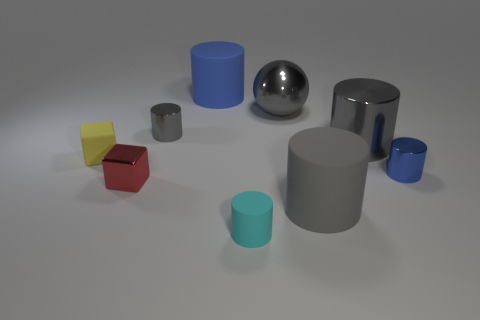Subtract all gray balls. How many gray cylinders are left? 3 Subtract all blue cylinders. How many cylinders are left? 4 Subtract all gray metal cylinders. How many cylinders are left? 4 Subtract all yellow cylinders. Subtract all red cubes. How many cylinders are left? 6 Add 1 cyan objects. How many objects exist? 10 Subtract all cubes. How many objects are left? 7 Subtract all tiny gray cylinders. Subtract all large gray shiny things. How many objects are left? 6 Add 1 yellow cubes. How many yellow cubes are left? 2 Add 6 large cyan objects. How many large cyan objects exist? 6 Subtract 1 gray balls. How many objects are left? 8 